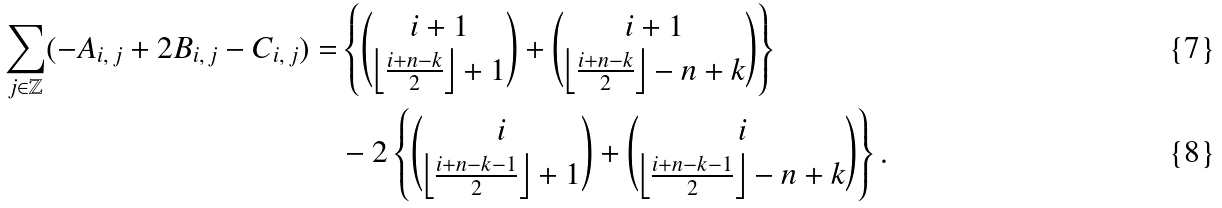<formula> <loc_0><loc_0><loc_500><loc_500>\sum _ { j \in \mathbb { Z } } ( - A _ { i , \, j } + 2 B _ { i , \, j } - C _ { i , \, j } ) = & \left \{ \binom { i + 1 } { \left \lfloor \frac { i + n - k } 2 \right \rfloor + 1 } + \binom { i + 1 } { \left \lfloor \frac { i + n - k } 2 \right \rfloor - n + k } \right \} \\ & - 2 \left \{ \binom { i } { \left \lfloor \frac { i + n - k - 1 } 2 \right \rfloor + 1 } + \binom { i } { \left \lfloor \frac { i + n - k - 1 } 2 \right \rfloor - n + k } \right \} .</formula> 